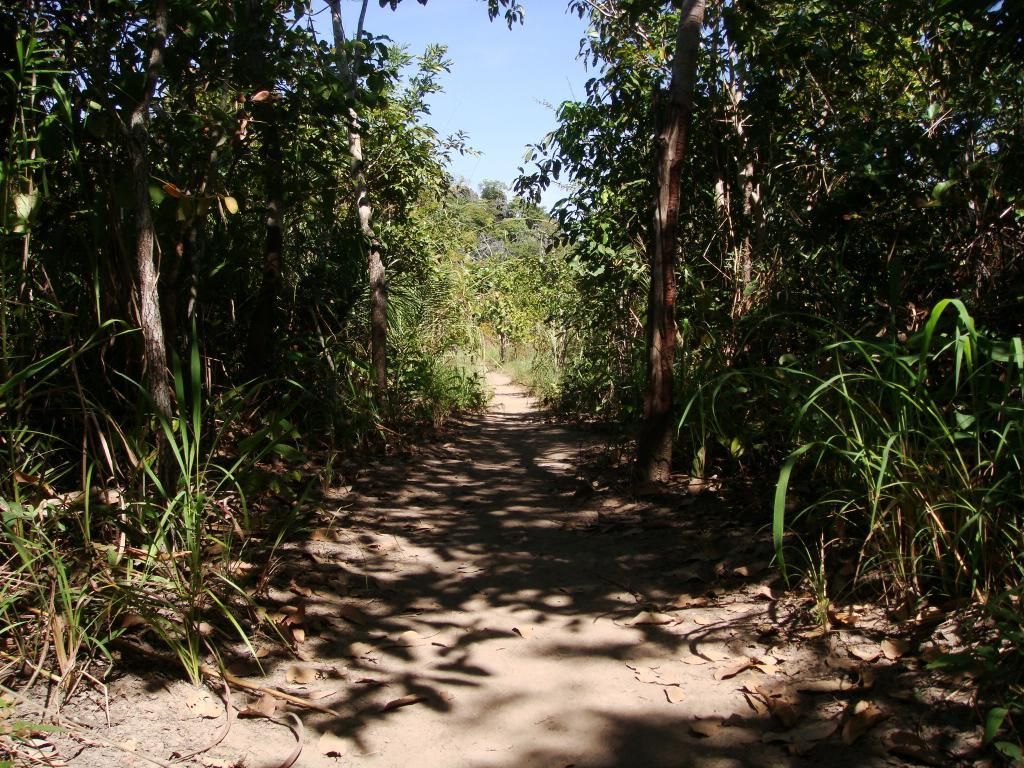What type of path is visible in the image? There is a footpath in the image. What can be seen on both sides of the footpath? There are trees on both sides of the footpath. What type of waste can be seen discarded along the footpath in the image? There is no waste visible along the footpath in the image. How much salt is present on the footpath in the image? There is no salt present on the footpath in the image. 